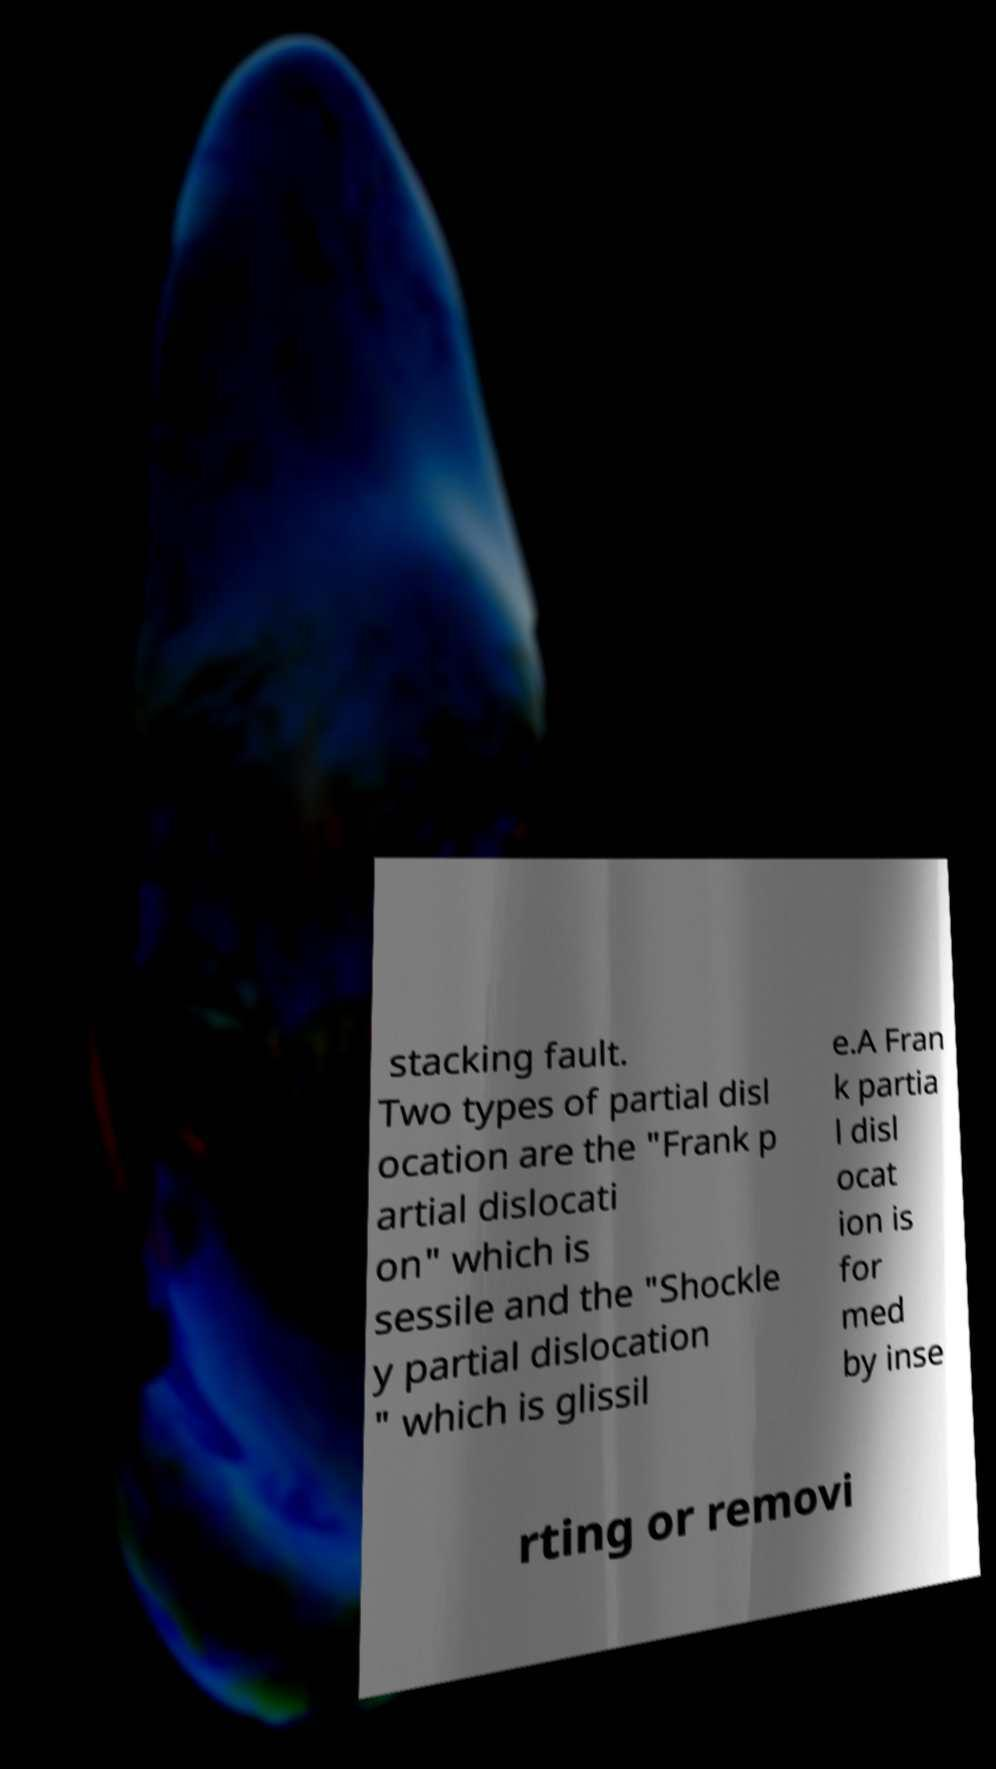Could you extract and type out the text from this image? stacking fault. Two types of partial disl ocation are the "Frank p artial dislocati on" which is sessile and the "Shockle y partial dislocation " which is glissil e.A Fran k partia l disl ocat ion is for med by inse rting or removi 